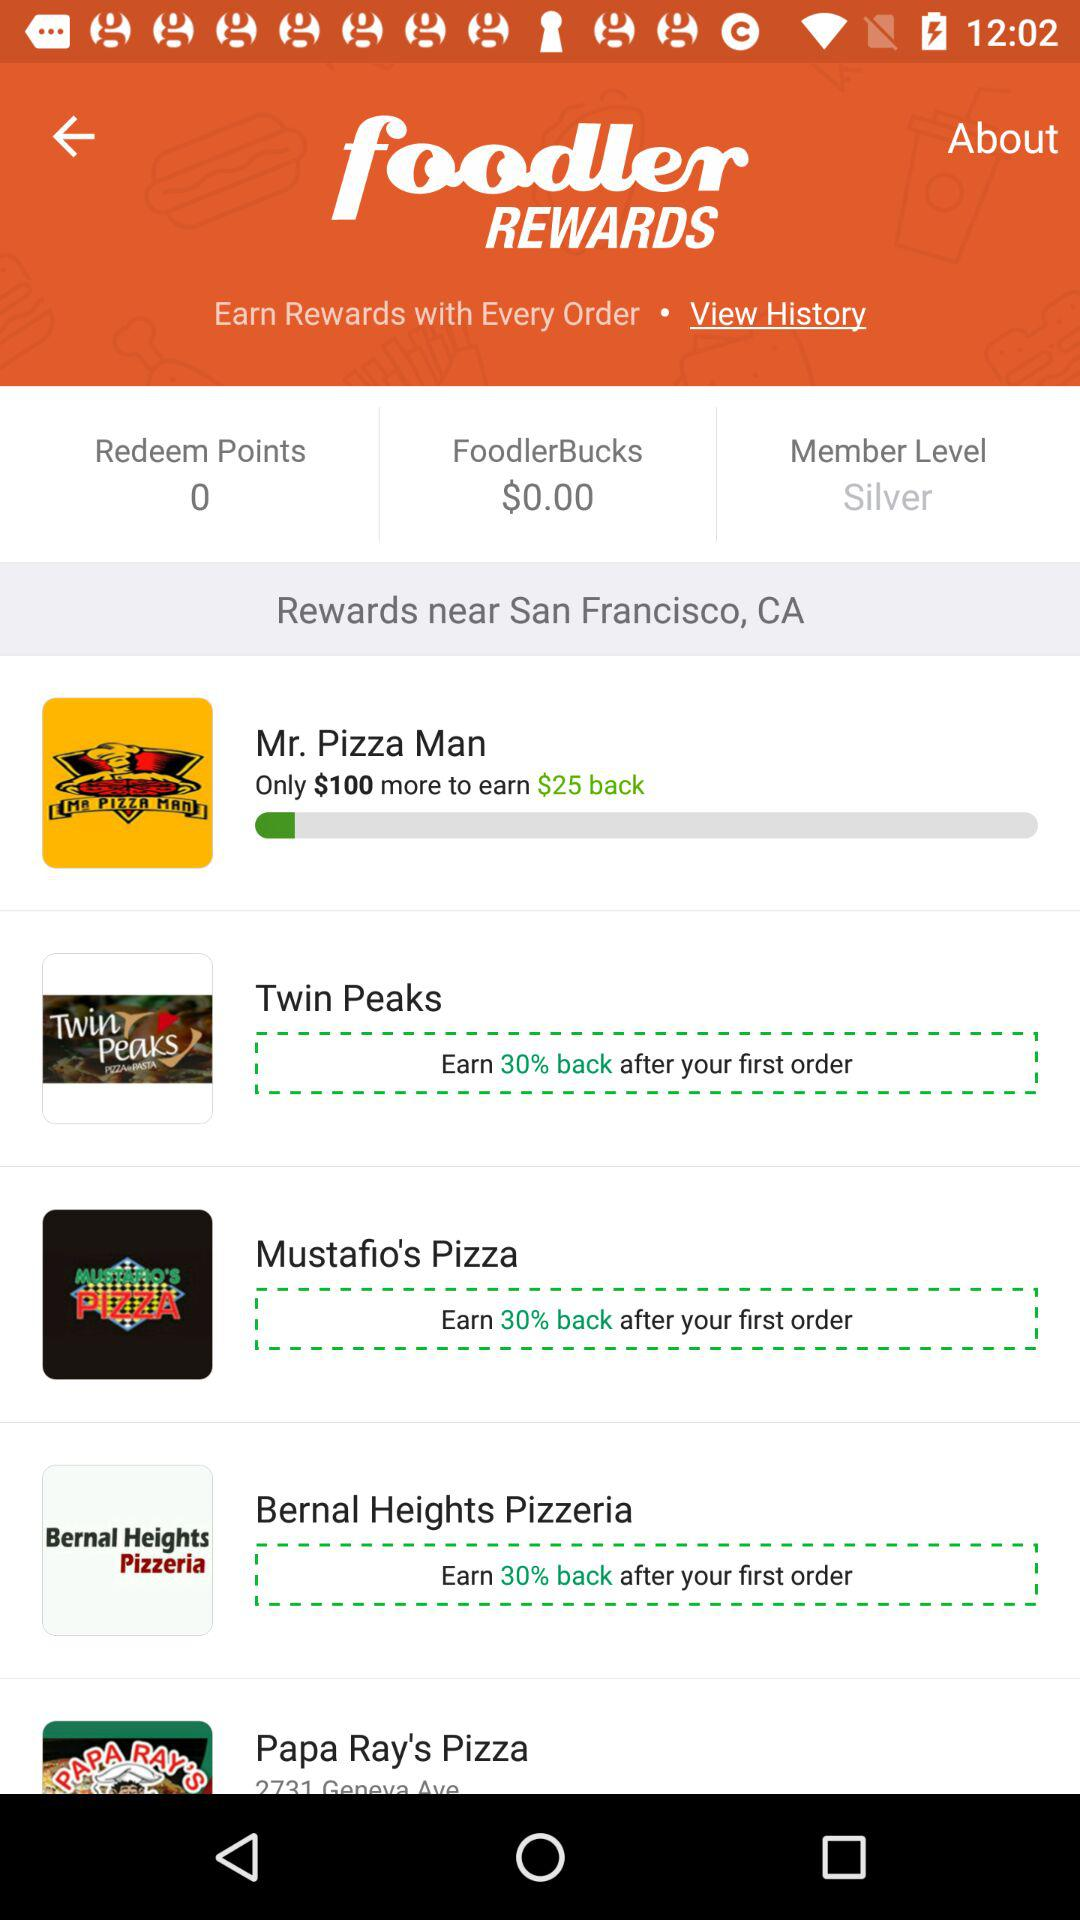What is the level of membership? The level of membership is "Silver". 